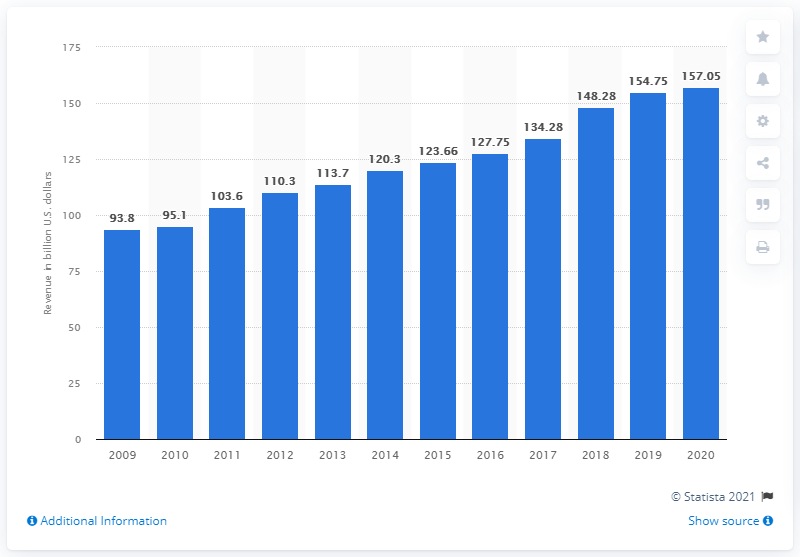Point out several critical features in this image. The combined global revenue of the Big Four accounting firms in 2020 was $157.05 billion. 